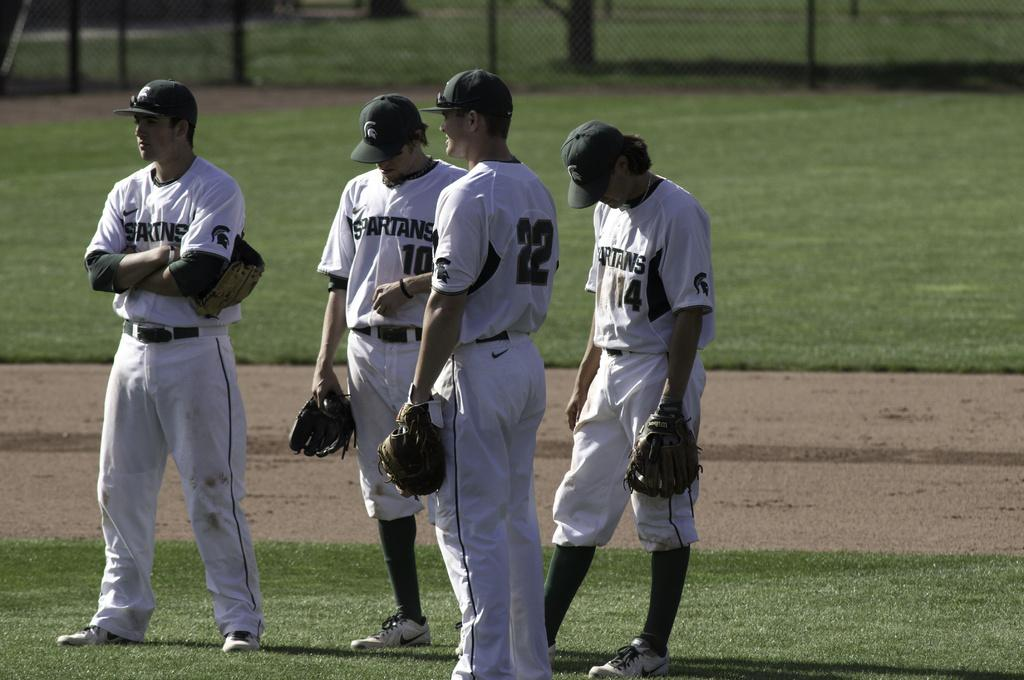<image>
Share a concise interpretation of the image provided. some baseball players with one wearing the number 22 